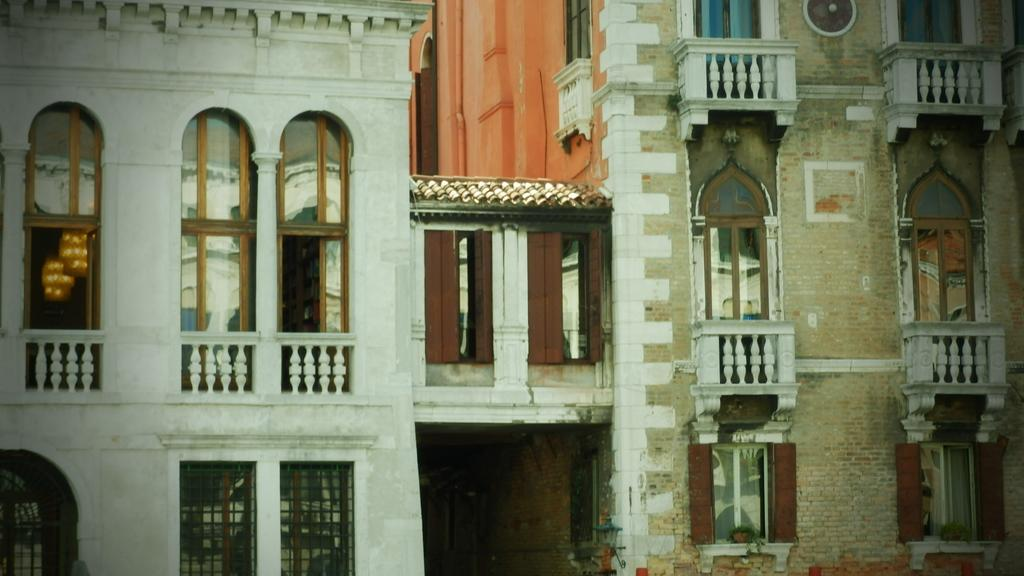What is the main subject in the center of the image? There is a building in the center of the image. What feature can be seen on the building? The building has windows. What additional object is present in the image? There is a railing in the image. What type of beef is being served in the image? There is no beef present in the image; it features a building with windows and a railing. How many buckets are visible in the image? There are no buckets present in the image. 